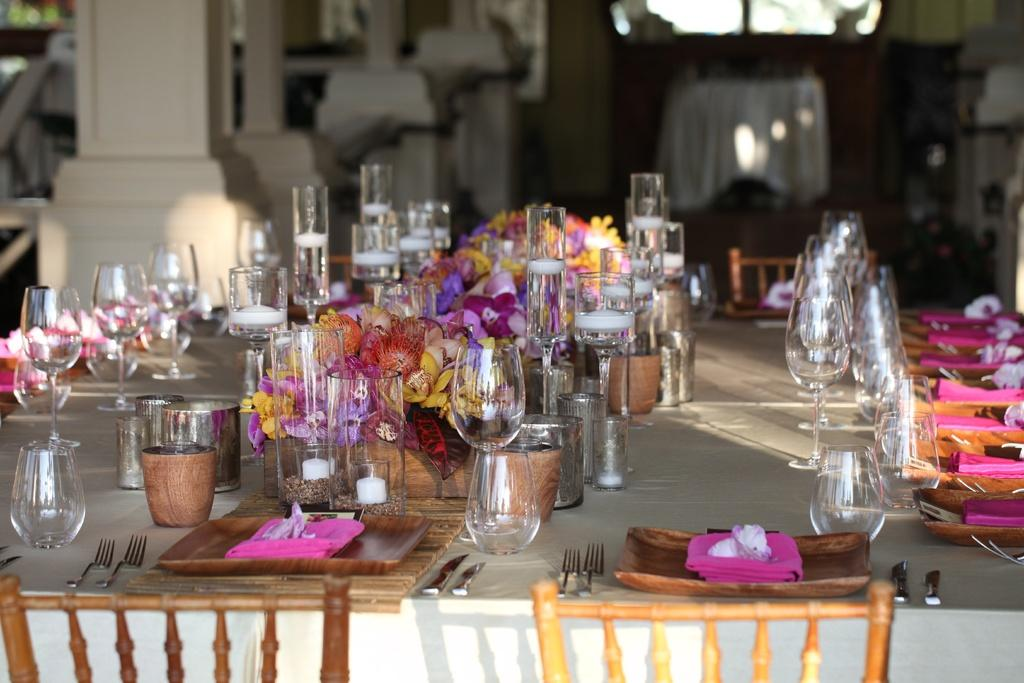What type of furniture is in the image? There is a dining table in the image. What items can be seen on the table? Plates, forks, wine glasses, and bowls are on the table. What decorative element is in the middle of the table? Flowers are in the middle of the table. What type of seating is in front of the table? Chairs are in front of the table. What type of room does the setting suggest? The setting suggests a dining room. What type of mint is growing on the table in the image? There is no mint growing on the table in the image; it features a dining table with various items on it. What type of battle is depicted in the image? There is no battle depicted in the image; it shows a dining table with plates, forks, wine glasses, bowls, flowers, and chairs. 